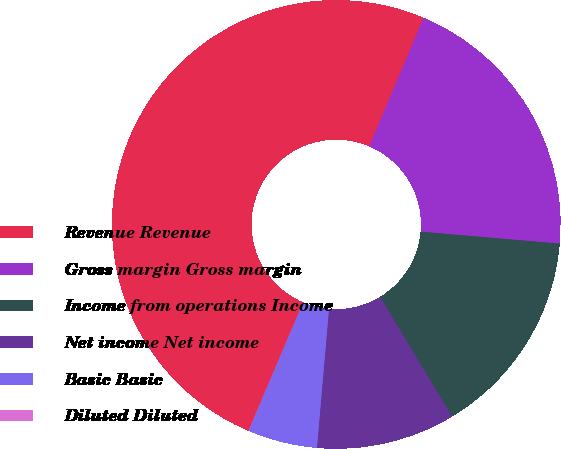<chart> <loc_0><loc_0><loc_500><loc_500><pie_chart><fcel>Revenue Revenue<fcel>Gross margin Gross margin<fcel>Income from operations Income<fcel>Net income Net income<fcel>Basic Basic<fcel>Diluted Diluted<nl><fcel>49.97%<fcel>20.0%<fcel>15.0%<fcel>10.01%<fcel>5.01%<fcel>0.01%<nl></chart> 